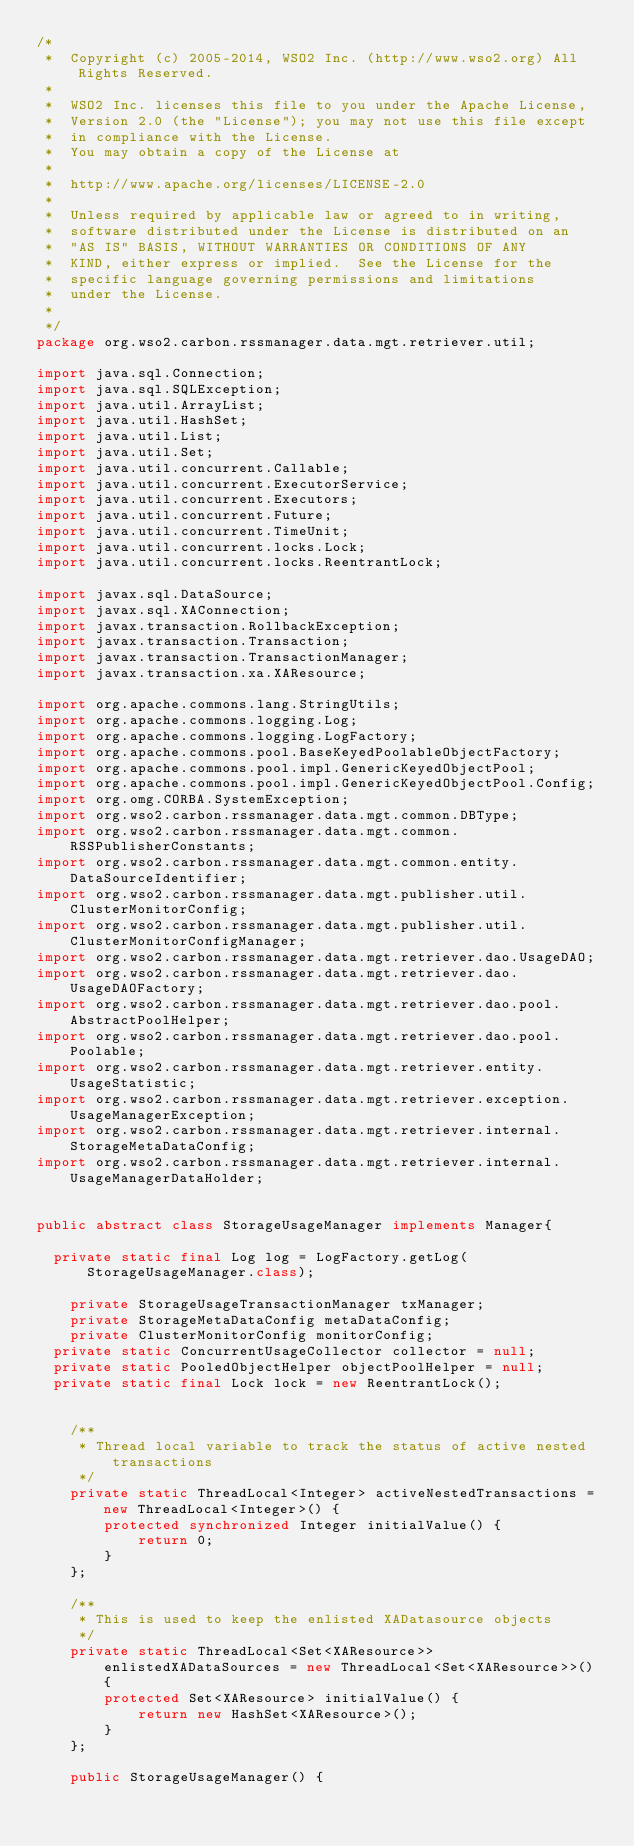<code> <loc_0><loc_0><loc_500><loc_500><_Java_>/*
 *  Copyright (c) 2005-2014, WSO2 Inc. (http://www.wso2.org) All Rights Reserved.
 *
 *  WSO2 Inc. licenses this file to you under the Apache License,
 *  Version 2.0 (the "License"); you may not use this file except
 *  in compliance with the License.
 *  You may obtain a copy of the License at
 *
 *  http://www.apache.org/licenses/LICENSE-2.0
 *
 *  Unless required by applicable law or agreed to in writing,
 *  software distributed under the License is distributed on an
 *  "AS IS" BASIS, WITHOUT WARRANTIES OR CONDITIONS OF ANY
 *  KIND, either express or implied.  See the License for the
 *  specific language governing permissions and limitations
 *  under the License.
 *
 */
package org.wso2.carbon.rssmanager.data.mgt.retriever.util;

import java.sql.Connection;
import java.sql.SQLException;
import java.util.ArrayList;
import java.util.HashSet;
import java.util.List;
import java.util.Set;
import java.util.concurrent.Callable;
import java.util.concurrent.ExecutorService;
import java.util.concurrent.Executors;
import java.util.concurrent.Future;
import java.util.concurrent.TimeUnit;
import java.util.concurrent.locks.Lock;
import java.util.concurrent.locks.ReentrantLock;

import javax.sql.DataSource;
import javax.sql.XAConnection;
import javax.transaction.RollbackException;
import javax.transaction.Transaction;
import javax.transaction.TransactionManager;
import javax.transaction.xa.XAResource;

import org.apache.commons.lang.StringUtils;
import org.apache.commons.logging.Log;
import org.apache.commons.logging.LogFactory;
import org.apache.commons.pool.BaseKeyedPoolableObjectFactory;
import org.apache.commons.pool.impl.GenericKeyedObjectPool;
import org.apache.commons.pool.impl.GenericKeyedObjectPool.Config;
import org.omg.CORBA.SystemException;
import org.wso2.carbon.rssmanager.data.mgt.common.DBType;
import org.wso2.carbon.rssmanager.data.mgt.common.RSSPublisherConstants;
import org.wso2.carbon.rssmanager.data.mgt.common.entity.DataSourceIdentifier;
import org.wso2.carbon.rssmanager.data.mgt.publisher.util.ClusterMonitorConfig;
import org.wso2.carbon.rssmanager.data.mgt.publisher.util.ClusterMonitorConfigManager;
import org.wso2.carbon.rssmanager.data.mgt.retriever.dao.UsageDAO;
import org.wso2.carbon.rssmanager.data.mgt.retriever.dao.UsageDAOFactory;
import org.wso2.carbon.rssmanager.data.mgt.retriever.dao.pool.AbstractPoolHelper;
import org.wso2.carbon.rssmanager.data.mgt.retriever.dao.pool.Poolable;
import org.wso2.carbon.rssmanager.data.mgt.retriever.entity.UsageStatistic;
import org.wso2.carbon.rssmanager.data.mgt.retriever.exception.UsageManagerException;
import org.wso2.carbon.rssmanager.data.mgt.retriever.internal.StorageMetaDataConfig;
import org.wso2.carbon.rssmanager.data.mgt.retriever.internal.UsageManagerDataHolder;


public abstract class StorageUsageManager implements Manager{
	
	private static final Log log = LogFactory.getLog(StorageUsageManager.class);

    private StorageUsageTransactionManager txManager;
    private StorageMetaDataConfig metaDataConfig;
    private ClusterMonitorConfig monitorConfig;
	private static ConcurrentUsageCollector collector = null;
	private static PooledObjectHelper objectPoolHelper = null;
	private static final Lock lock = new ReentrantLock();
    

    /**
     * Thread local variable to track the status of active nested transactions
     */
    private static ThreadLocal<Integer> activeNestedTransactions = new ThreadLocal<Integer>() {
        protected synchronized Integer initialValue() {
            return 0;
        }
    };

    /**
     * This is used to keep the enlisted XADatasource objects
     */
    private static ThreadLocal<Set<XAResource>> enlistedXADataSources = new ThreadLocal<Set<XAResource>>() {
        protected Set<XAResource> initialValue() {
            return new HashSet<XAResource>();
        }
    };

    public StorageUsageManager() {</code> 